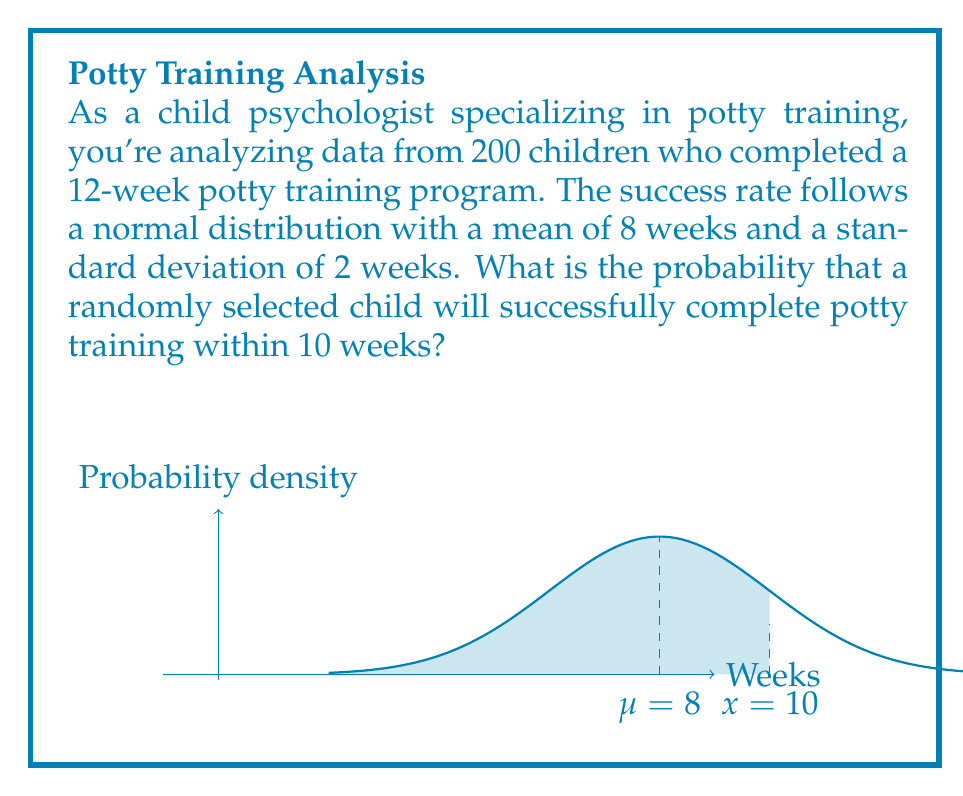Solve this math problem. To solve this problem, we need to use the properties of the normal distribution and calculate the z-score.

Step 1: Identify the given information
- Mean (μ) = 8 weeks
- Standard deviation (σ) = 2 weeks
- Time frame (x) = 10 weeks

Step 2: Calculate the z-score
The z-score represents how many standard deviations the given value is from the mean.

$$ z = \frac{x - \mu}{\sigma} = \frac{10 - 8}{2} = 1 $$

Step 3: Use the standard normal distribution table or calculator
We need to find the area under the normal curve to the left of z = 1.

Using a standard normal distribution table or calculator, we find:
$$ P(Z \leq 1) \approx 0.8413 $$

This means that approximately 84.13% of the area under the normal curve lies to the left of z = 1.

Step 4: Interpret the result
The probability that a randomly selected child will successfully complete potty training within 10 weeks is about 0.8413 or 84.13%.
Answer: 0.8413 (or 84.13%) 